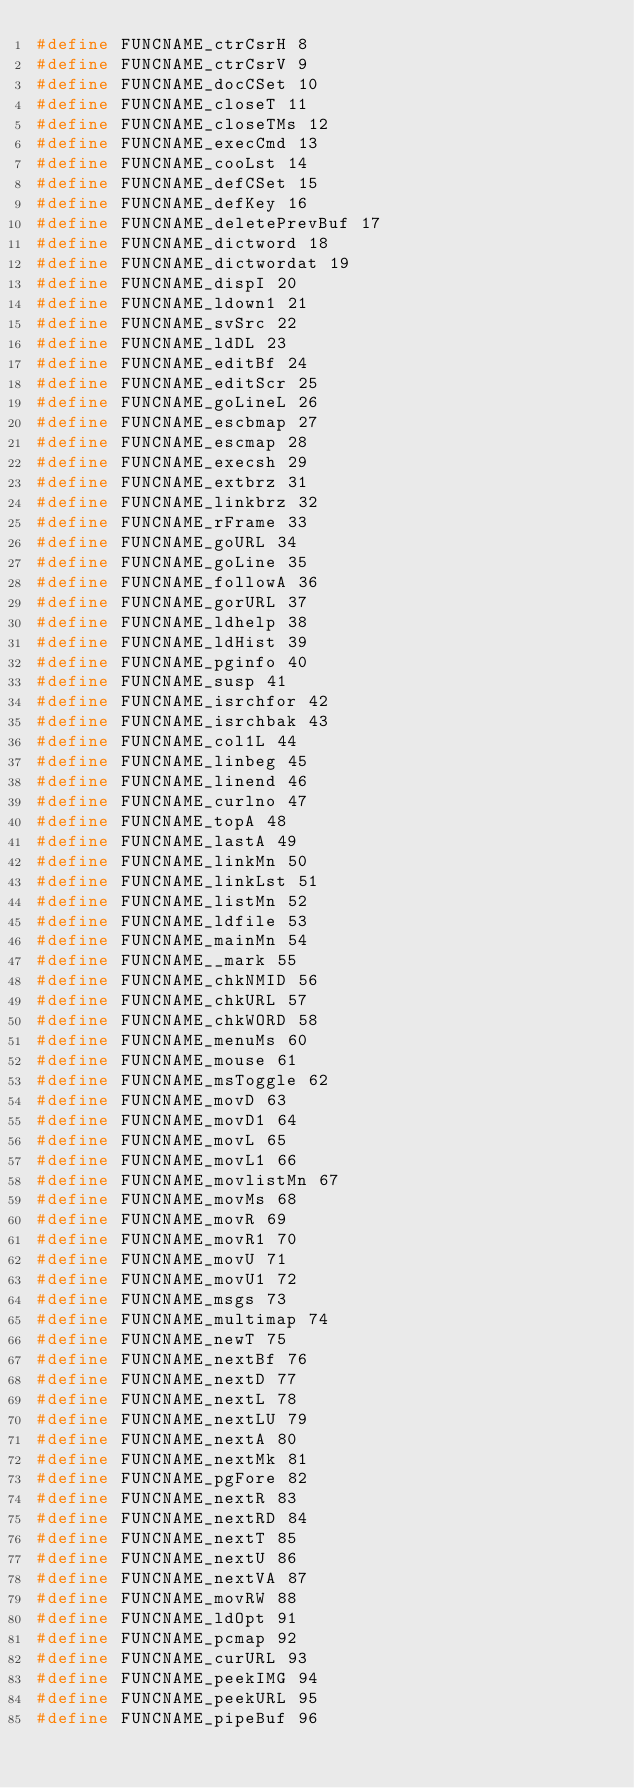<code> <loc_0><loc_0><loc_500><loc_500><_C_>#define FUNCNAME_ctrCsrH 8
#define FUNCNAME_ctrCsrV 9
#define FUNCNAME_docCSet 10
#define FUNCNAME_closeT 11
#define FUNCNAME_closeTMs 12
#define FUNCNAME_execCmd 13
#define FUNCNAME_cooLst 14
#define FUNCNAME_defCSet 15
#define FUNCNAME_defKey 16
#define FUNCNAME_deletePrevBuf 17
#define FUNCNAME_dictword 18
#define FUNCNAME_dictwordat 19
#define FUNCNAME_dispI 20
#define FUNCNAME_ldown1 21
#define FUNCNAME_svSrc 22
#define FUNCNAME_ldDL 23
#define FUNCNAME_editBf 24
#define FUNCNAME_editScr 25
#define FUNCNAME_goLineL 26
#define FUNCNAME_escbmap 27
#define FUNCNAME_escmap 28
#define FUNCNAME_execsh 29
#define FUNCNAME_extbrz 31
#define FUNCNAME_linkbrz 32
#define FUNCNAME_rFrame 33
#define FUNCNAME_goURL 34
#define FUNCNAME_goLine 35
#define FUNCNAME_followA 36
#define FUNCNAME_gorURL 37
#define FUNCNAME_ldhelp 38
#define FUNCNAME_ldHist 39
#define FUNCNAME_pginfo 40
#define FUNCNAME_susp 41
#define FUNCNAME_isrchfor 42
#define FUNCNAME_isrchbak 43
#define FUNCNAME_col1L 44
#define FUNCNAME_linbeg 45
#define FUNCNAME_linend 46
#define FUNCNAME_curlno 47
#define FUNCNAME_topA 48
#define FUNCNAME_lastA 49
#define FUNCNAME_linkMn 50
#define FUNCNAME_linkLst 51
#define FUNCNAME_listMn 52
#define FUNCNAME_ldfile 53
#define FUNCNAME_mainMn 54
#define FUNCNAME__mark 55
#define FUNCNAME_chkNMID 56
#define FUNCNAME_chkURL 57
#define FUNCNAME_chkWORD 58
#define FUNCNAME_menuMs 60
#define FUNCNAME_mouse 61
#define FUNCNAME_msToggle 62
#define FUNCNAME_movD 63
#define FUNCNAME_movD1 64
#define FUNCNAME_movL 65
#define FUNCNAME_movL1 66
#define FUNCNAME_movlistMn 67
#define FUNCNAME_movMs 68
#define FUNCNAME_movR 69
#define FUNCNAME_movR1 70
#define FUNCNAME_movU 71
#define FUNCNAME_movU1 72
#define FUNCNAME_msgs 73
#define FUNCNAME_multimap 74
#define FUNCNAME_newT 75
#define FUNCNAME_nextBf 76
#define FUNCNAME_nextD 77
#define FUNCNAME_nextL 78
#define FUNCNAME_nextLU 79
#define FUNCNAME_nextA 80
#define FUNCNAME_nextMk 81
#define FUNCNAME_pgFore 82
#define FUNCNAME_nextR 83
#define FUNCNAME_nextRD 84
#define FUNCNAME_nextT 85
#define FUNCNAME_nextU 86
#define FUNCNAME_nextVA 87
#define FUNCNAME_movRW 88
#define FUNCNAME_ldOpt 91
#define FUNCNAME_pcmap 92
#define FUNCNAME_curURL 93
#define FUNCNAME_peekIMG 94
#define FUNCNAME_peekURL 95
#define FUNCNAME_pipeBuf 96</code> 